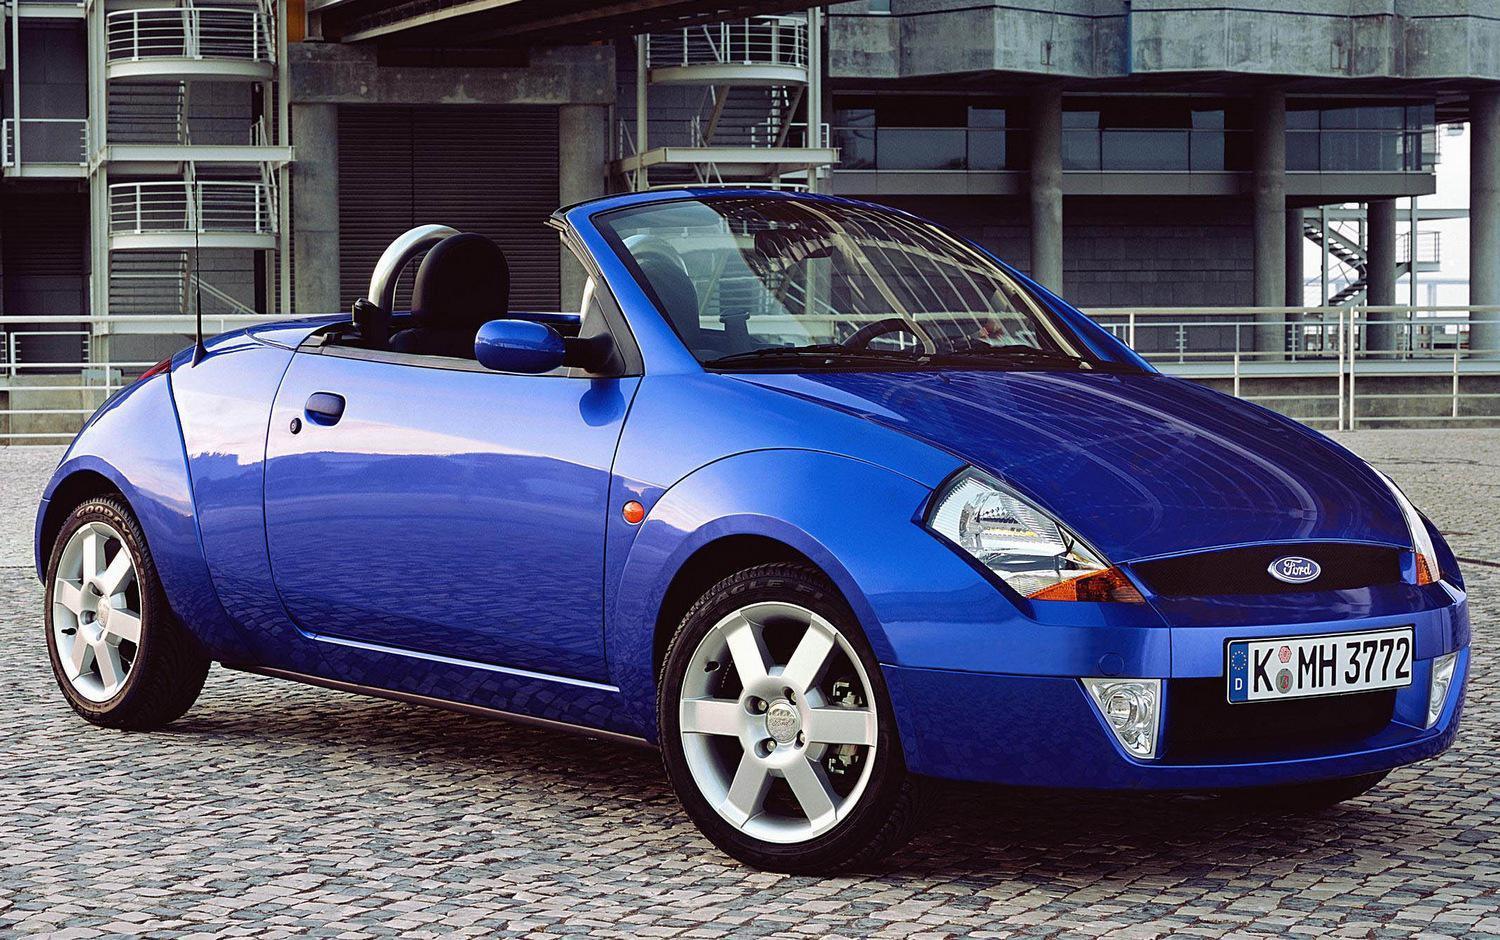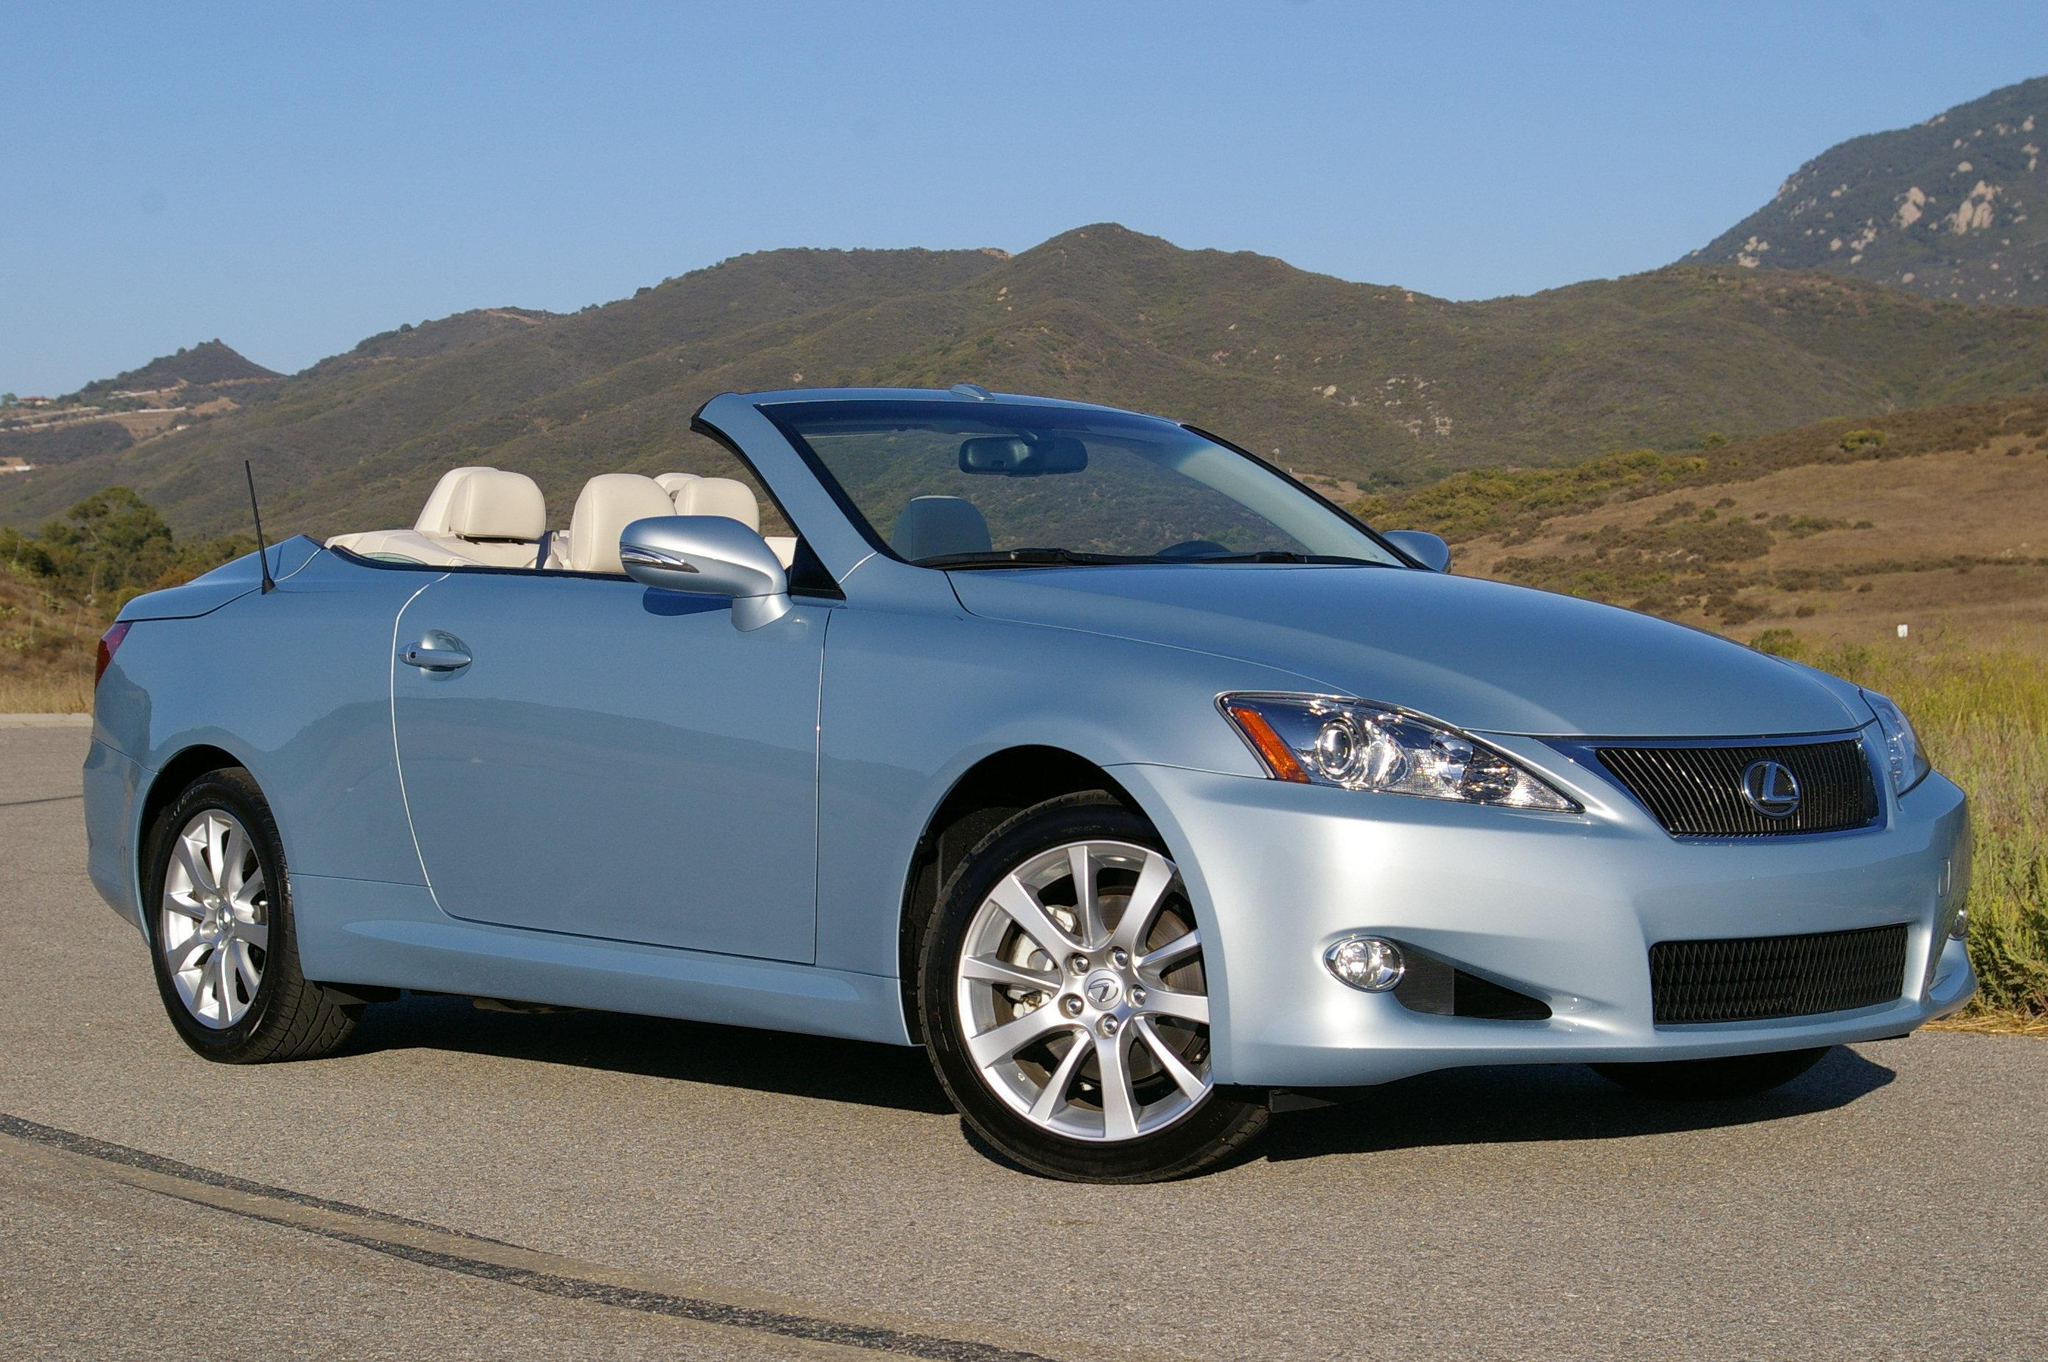The first image is the image on the left, the second image is the image on the right. Analyze the images presented: Is the assertion "there is a parked convertible on the road in fron't of a mountain background" valid? Answer yes or no. Yes. The first image is the image on the left, the second image is the image on the right. For the images displayed, is the sentence "The car in the image on the left is parked in front of a building." factually correct? Answer yes or no. Yes. 